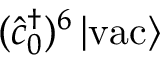Convert formula to latex. <formula><loc_0><loc_0><loc_500><loc_500>( \hat { c } _ { 0 } ^ { \dagger } ) ^ { 6 } \left | v a c \right \rangle</formula> 